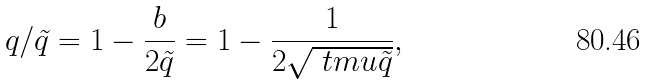<formula> <loc_0><loc_0><loc_500><loc_500>q / \tilde { q } = 1 - \frac { b } { 2 \tilde { q } } = 1 - \frac { 1 } { 2 \sqrt { \ t m u \tilde { q } } } ,</formula> 